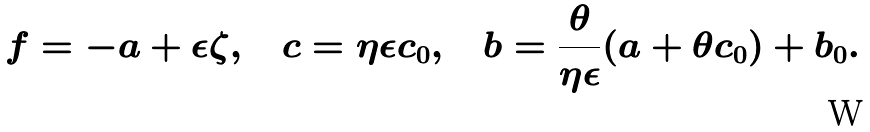Convert formula to latex. <formula><loc_0><loc_0><loc_500><loc_500>f = - a + \epsilon \zeta , \quad c = \eta \epsilon c _ { 0 } , \quad b = \frac { \theta } { \eta \epsilon } ( a + \theta c _ { 0 } ) + b _ { 0 } .</formula> 